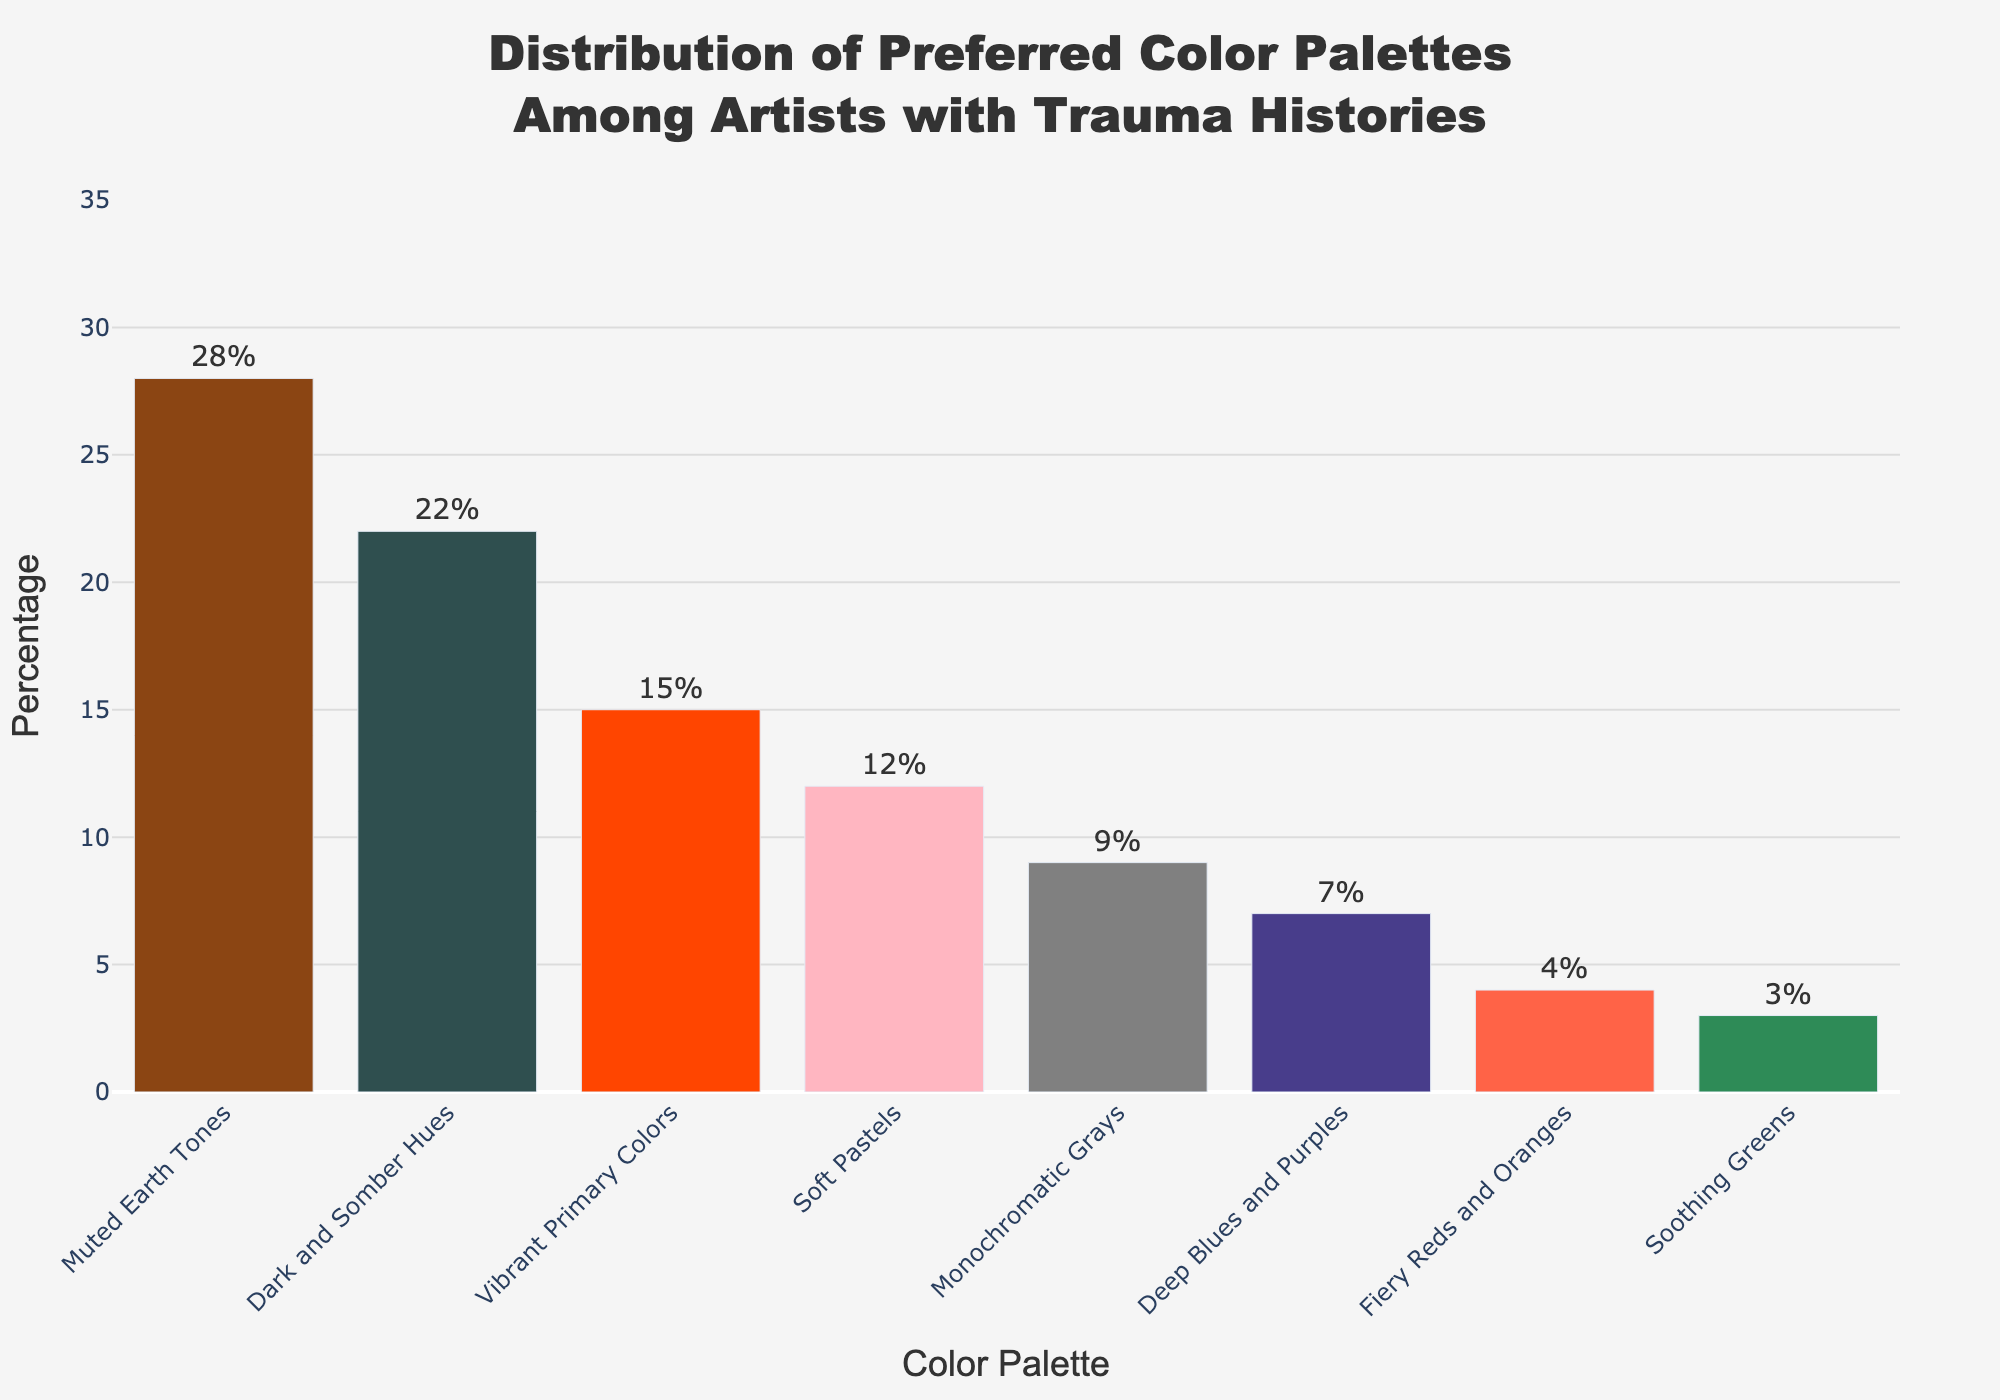Which color palette has the highest preference among artists with trauma histories? The bar representing "Muted Earth Tones" is the tallest, which indicates that it has the highest percentage.
Answer: Muted Earth Tones What is the total percentage preference for "Vibrant Primary Colors" and "Soft Pastels"? The "Vibrant Primary Colors" bar is labeled 15% and "Soft Pastels" is labeled 12%. Adding these percentages together gives 15% + 12% = 27%.
Answer: 27% Which is preferred more, "Deep Blues and Purples" or "Monochromatic Grays"? Compare the heights of the bars for "Deep Blues and Purples" and "Monochromatic Grays." "Monochromatic Grays" has a higher percentage (9%) compared to "Deep Blues and Purples" (7%).
Answer: Monochromatic Grays What is the difference in preference percentage between "Dark and Somber Hues" and "Fiery Reds and Oranges"? The percentage for "Dark and Somber Hues" is 22% and for "Fiery Reds and Oranges" is 4%. The difference is 22% - 4% = 18%.
Answer: 18% How many color palettes have a preference percentage lower than 10%? Counting the bars whose percentages are below 10%, we have "Monochromatic Grays" (9%), "Deep Blues and Purples" (7%), "Fiery Reds and Oranges" (4%), and "Soothing Greens" (3%). There are 4 palettes in total.
Answer: 4 Is the preference percentage for "Muted Earth Tones" more than twice that for "Soothing Greens"? The percentage for "Muted Earth Tones" is 28%, and for "Soothing Greens" it is 3%. Doubling 3% gives 6%, which is still less than 28%. Hence, 28% is more than twice 3%.
Answer: Yes Which three color palettes have the highest preference percentages? Observing the three tallest bars in the chart, they correspond to "Muted Earth Tones," "Dark and Somber Hues," and "Vibrant Primary Colors."
Answer: Muted Earth Tones, Dark and Somber Hues, Vibrant Primary Colors What is the combined percentage preference for "Dark and Somber Hues" and "Muted Earth Tones"? The percentage for "Dark and Somber Hues" is 22% and for "Muted Earth Tones" is 28%. Adding these together gives 22% + 28% = 50%.
Answer: 50% What is the average preference percentage for "Monochromatic Grays," "Deep Blues and Purples," and "Fiery Reds and Oranges"? Adding the percentages for these palettes: 9% (Monochromatic Grays) + 7% (Deep Blues and Purples) + 4% (Fiery Reds and Oranges), we get 20%. Dividing by the number of palettes (3) gives an average of 20% / 3 ≈ 6.67%.
Answer: 6.67% Does any color palette have a preference percentage exactly equal to 12%? Looking at the percentages labeled on the bars, "Soft Pastels" has a preference percentage of 12%.
Answer: Yes 